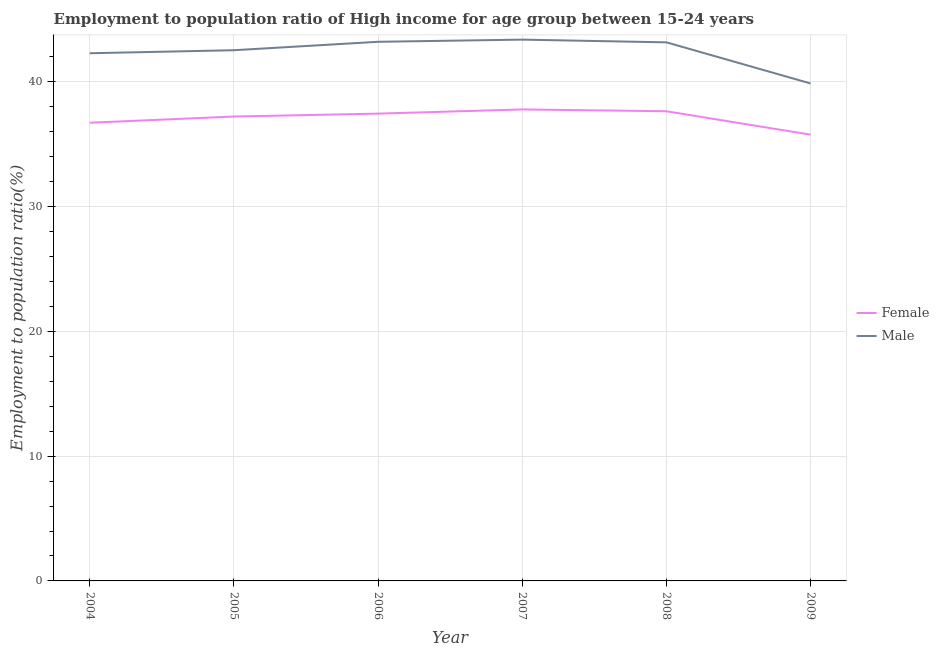How many different coloured lines are there?
Provide a succinct answer. 2. Does the line corresponding to employment to population ratio(female) intersect with the line corresponding to employment to population ratio(male)?
Give a very brief answer. No. Is the number of lines equal to the number of legend labels?
Offer a terse response. Yes. What is the employment to population ratio(male) in 2006?
Give a very brief answer. 43.22. Across all years, what is the maximum employment to population ratio(male)?
Give a very brief answer. 43.39. Across all years, what is the minimum employment to population ratio(female)?
Your answer should be very brief. 35.77. In which year was the employment to population ratio(female) maximum?
Offer a terse response. 2007. What is the total employment to population ratio(female) in the graph?
Offer a very short reply. 222.62. What is the difference between the employment to population ratio(male) in 2005 and that in 2006?
Keep it short and to the point. -0.68. What is the difference between the employment to population ratio(female) in 2004 and the employment to population ratio(male) in 2006?
Make the answer very short. -6.49. What is the average employment to population ratio(female) per year?
Keep it short and to the point. 37.1. In the year 2009, what is the difference between the employment to population ratio(male) and employment to population ratio(female)?
Give a very brief answer. 4.1. In how many years, is the employment to population ratio(female) greater than 14 %?
Offer a very short reply. 6. What is the ratio of the employment to population ratio(male) in 2005 to that in 2008?
Make the answer very short. 0.99. Is the difference between the employment to population ratio(female) in 2007 and 2009 greater than the difference between the employment to population ratio(male) in 2007 and 2009?
Your answer should be very brief. No. What is the difference between the highest and the second highest employment to population ratio(male)?
Offer a very short reply. 0.17. What is the difference between the highest and the lowest employment to population ratio(male)?
Provide a short and direct response. 3.51. In how many years, is the employment to population ratio(male) greater than the average employment to population ratio(male) taken over all years?
Offer a terse response. 4. Is the sum of the employment to population ratio(female) in 2006 and 2009 greater than the maximum employment to population ratio(male) across all years?
Provide a short and direct response. Yes. Does the employment to population ratio(male) monotonically increase over the years?
Keep it short and to the point. No. How many lines are there?
Make the answer very short. 2. What is the difference between two consecutive major ticks on the Y-axis?
Ensure brevity in your answer.  10. Does the graph contain grids?
Give a very brief answer. Yes. Where does the legend appear in the graph?
Offer a very short reply. Center right. How many legend labels are there?
Provide a succinct answer. 2. What is the title of the graph?
Provide a short and direct response. Employment to population ratio of High income for age group between 15-24 years. Does "Infant" appear as one of the legend labels in the graph?
Give a very brief answer. No. What is the label or title of the X-axis?
Keep it short and to the point. Year. What is the Employment to population ratio(%) in Female in 2004?
Provide a short and direct response. 36.73. What is the Employment to population ratio(%) of Male in 2004?
Offer a terse response. 42.3. What is the Employment to population ratio(%) in Female in 2005?
Offer a very short reply. 37.23. What is the Employment to population ratio(%) in Male in 2005?
Offer a very short reply. 42.54. What is the Employment to population ratio(%) in Female in 2006?
Ensure brevity in your answer.  37.46. What is the Employment to population ratio(%) of Male in 2006?
Give a very brief answer. 43.22. What is the Employment to population ratio(%) in Female in 2007?
Your answer should be very brief. 37.79. What is the Employment to population ratio(%) of Male in 2007?
Provide a succinct answer. 43.39. What is the Employment to population ratio(%) in Female in 2008?
Give a very brief answer. 37.65. What is the Employment to population ratio(%) in Male in 2008?
Offer a very short reply. 43.17. What is the Employment to population ratio(%) of Female in 2009?
Provide a succinct answer. 35.77. What is the Employment to population ratio(%) of Male in 2009?
Make the answer very short. 39.88. Across all years, what is the maximum Employment to population ratio(%) in Female?
Make the answer very short. 37.79. Across all years, what is the maximum Employment to population ratio(%) in Male?
Make the answer very short. 43.39. Across all years, what is the minimum Employment to population ratio(%) in Female?
Your response must be concise. 35.77. Across all years, what is the minimum Employment to population ratio(%) of Male?
Provide a succinct answer. 39.88. What is the total Employment to population ratio(%) in Female in the graph?
Provide a short and direct response. 222.62. What is the total Employment to population ratio(%) of Male in the graph?
Give a very brief answer. 254.49. What is the difference between the Employment to population ratio(%) of Female in 2004 and that in 2005?
Keep it short and to the point. -0.5. What is the difference between the Employment to population ratio(%) of Male in 2004 and that in 2005?
Offer a very short reply. -0.24. What is the difference between the Employment to population ratio(%) of Female in 2004 and that in 2006?
Make the answer very short. -0.73. What is the difference between the Employment to population ratio(%) of Male in 2004 and that in 2006?
Keep it short and to the point. -0.92. What is the difference between the Employment to population ratio(%) in Female in 2004 and that in 2007?
Your response must be concise. -1.07. What is the difference between the Employment to population ratio(%) in Male in 2004 and that in 2007?
Offer a very short reply. -1.09. What is the difference between the Employment to population ratio(%) of Female in 2004 and that in 2008?
Offer a terse response. -0.92. What is the difference between the Employment to population ratio(%) of Male in 2004 and that in 2008?
Offer a very short reply. -0.87. What is the difference between the Employment to population ratio(%) in Female in 2004 and that in 2009?
Offer a very short reply. 0.96. What is the difference between the Employment to population ratio(%) in Male in 2004 and that in 2009?
Ensure brevity in your answer.  2.42. What is the difference between the Employment to population ratio(%) of Female in 2005 and that in 2006?
Your response must be concise. -0.23. What is the difference between the Employment to population ratio(%) of Male in 2005 and that in 2006?
Keep it short and to the point. -0.68. What is the difference between the Employment to population ratio(%) in Female in 2005 and that in 2007?
Your answer should be very brief. -0.57. What is the difference between the Employment to population ratio(%) of Male in 2005 and that in 2007?
Provide a succinct answer. -0.85. What is the difference between the Employment to population ratio(%) in Female in 2005 and that in 2008?
Your answer should be very brief. -0.42. What is the difference between the Employment to population ratio(%) in Male in 2005 and that in 2008?
Give a very brief answer. -0.63. What is the difference between the Employment to population ratio(%) of Female in 2005 and that in 2009?
Make the answer very short. 1.45. What is the difference between the Employment to population ratio(%) of Male in 2005 and that in 2009?
Give a very brief answer. 2.66. What is the difference between the Employment to population ratio(%) of Female in 2006 and that in 2007?
Your response must be concise. -0.34. What is the difference between the Employment to population ratio(%) in Male in 2006 and that in 2007?
Provide a succinct answer. -0.17. What is the difference between the Employment to population ratio(%) in Female in 2006 and that in 2008?
Ensure brevity in your answer.  -0.19. What is the difference between the Employment to population ratio(%) in Male in 2006 and that in 2008?
Keep it short and to the point. 0.04. What is the difference between the Employment to population ratio(%) of Female in 2006 and that in 2009?
Provide a succinct answer. 1.69. What is the difference between the Employment to population ratio(%) in Male in 2006 and that in 2009?
Keep it short and to the point. 3.34. What is the difference between the Employment to population ratio(%) of Female in 2007 and that in 2008?
Provide a short and direct response. 0.15. What is the difference between the Employment to population ratio(%) of Male in 2007 and that in 2008?
Make the answer very short. 0.22. What is the difference between the Employment to population ratio(%) of Female in 2007 and that in 2009?
Your answer should be very brief. 2.02. What is the difference between the Employment to population ratio(%) in Male in 2007 and that in 2009?
Ensure brevity in your answer.  3.51. What is the difference between the Employment to population ratio(%) in Female in 2008 and that in 2009?
Your response must be concise. 1.88. What is the difference between the Employment to population ratio(%) of Male in 2008 and that in 2009?
Your answer should be very brief. 3.3. What is the difference between the Employment to population ratio(%) in Female in 2004 and the Employment to population ratio(%) in Male in 2005?
Make the answer very short. -5.81. What is the difference between the Employment to population ratio(%) in Female in 2004 and the Employment to population ratio(%) in Male in 2006?
Your response must be concise. -6.49. What is the difference between the Employment to population ratio(%) of Female in 2004 and the Employment to population ratio(%) of Male in 2007?
Your answer should be compact. -6.66. What is the difference between the Employment to population ratio(%) of Female in 2004 and the Employment to population ratio(%) of Male in 2008?
Your response must be concise. -6.44. What is the difference between the Employment to population ratio(%) of Female in 2004 and the Employment to population ratio(%) of Male in 2009?
Give a very brief answer. -3.15. What is the difference between the Employment to population ratio(%) of Female in 2005 and the Employment to population ratio(%) of Male in 2006?
Make the answer very short. -5.99. What is the difference between the Employment to population ratio(%) of Female in 2005 and the Employment to population ratio(%) of Male in 2007?
Provide a short and direct response. -6.16. What is the difference between the Employment to population ratio(%) in Female in 2005 and the Employment to population ratio(%) in Male in 2008?
Your answer should be compact. -5.95. What is the difference between the Employment to population ratio(%) of Female in 2005 and the Employment to population ratio(%) of Male in 2009?
Provide a short and direct response. -2.65. What is the difference between the Employment to population ratio(%) of Female in 2006 and the Employment to population ratio(%) of Male in 2007?
Keep it short and to the point. -5.93. What is the difference between the Employment to population ratio(%) of Female in 2006 and the Employment to population ratio(%) of Male in 2008?
Make the answer very short. -5.71. What is the difference between the Employment to population ratio(%) of Female in 2006 and the Employment to population ratio(%) of Male in 2009?
Ensure brevity in your answer.  -2.42. What is the difference between the Employment to population ratio(%) in Female in 2007 and the Employment to population ratio(%) in Male in 2008?
Ensure brevity in your answer.  -5.38. What is the difference between the Employment to population ratio(%) of Female in 2007 and the Employment to population ratio(%) of Male in 2009?
Your response must be concise. -2.08. What is the difference between the Employment to population ratio(%) of Female in 2008 and the Employment to population ratio(%) of Male in 2009?
Your answer should be very brief. -2.23. What is the average Employment to population ratio(%) in Female per year?
Keep it short and to the point. 37.1. What is the average Employment to population ratio(%) in Male per year?
Your response must be concise. 42.42. In the year 2004, what is the difference between the Employment to population ratio(%) of Female and Employment to population ratio(%) of Male?
Make the answer very short. -5.57. In the year 2005, what is the difference between the Employment to population ratio(%) in Female and Employment to population ratio(%) in Male?
Provide a short and direct response. -5.32. In the year 2006, what is the difference between the Employment to population ratio(%) of Female and Employment to population ratio(%) of Male?
Offer a terse response. -5.76. In the year 2007, what is the difference between the Employment to population ratio(%) in Female and Employment to population ratio(%) in Male?
Offer a very short reply. -5.6. In the year 2008, what is the difference between the Employment to population ratio(%) of Female and Employment to population ratio(%) of Male?
Provide a succinct answer. -5.52. In the year 2009, what is the difference between the Employment to population ratio(%) in Female and Employment to population ratio(%) in Male?
Your answer should be very brief. -4.1. What is the ratio of the Employment to population ratio(%) of Female in 2004 to that in 2005?
Offer a very short reply. 0.99. What is the ratio of the Employment to population ratio(%) of Female in 2004 to that in 2006?
Your answer should be compact. 0.98. What is the ratio of the Employment to population ratio(%) in Male in 2004 to that in 2006?
Keep it short and to the point. 0.98. What is the ratio of the Employment to population ratio(%) of Female in 2004 to that in 2007?
Your response must be concise. 0.97. What is the ratio of the Employment to population ratio(%) in Male in 2004 to that in 2007?
Provide a short and direct response. 0.97. What is the ratio of the Employment to population ratio(%) in Female in 2004 to that in 2008?
Keep it short and to the point. 0.98. What is the ratio of the Employment to population ratio(%) in Male in 2004 to that in 2008?
Ensure brevity in your answer.  0.98. What is the ratio of the Employment to population ratio(%) in Female in 2004 to that in 2009?
Ensure brevity in your answer.  1.03. What is the ratio of the Employment to population ratio(%) in Male in 2004 to that in 2009?
Offer a terse response. 1.06. What is the ratio of the Employment to population ratio(%) in Male in 2005 to that in 2006?
Offer a very short reply. 0.98. What is the ratio of the Employment to population ratio(%) in Female in 2005 to that in 2007?
Keep it short and to the point. 0.98. What is the ratio of the Employment to population ratio(%) in Male in 2005 to that in 2007?
Keep it short and to the point. 0.98. What is the ratio of the Employment to population ratio(%) in Male in 2005 to that in 2008?
Give a very brief answer. 0.99. What is the ratio of the Employment to population ratio(%) of Female in 2005 to that in 2009?
Provide a short and direct response. 1.04. What is the ratio of the Employment to population ratio(%) in Male in 2005 to that in 2009?
Offer a terse response. 1.07. What is the ratio of the Employment to population ratio(%) of Male in 2006 to that in 2007?
Ensure brevity in your answer.  1. What is the ratio of the Employment to population ratio(%) in Male in 2006 to that in 2008?
Offer a very short reply. 1. What is the ratio of the Employment to population ratio(%) of Female in 2006 to that in 2009?
Keep it short and to the point. 1.05. What is the ratio of the Employment to population ratio(%) in Male in 2006 to that in 2009?
Your answer should be very brief. 1.08. What is the ratio of the Employment to population ratio(%) of Female in 2007 to that in 2008?
Give a very brief answer. 1. What is the ratio of the Employment to population ratio(%) of Female in 2007 to that in 2009?
Your response must be concise. 1.06. What is the ratio of the Employment to population ratio(%) in Male in 2007 to that in 2009?
Ensure brevity in your answer.  1.09. What is the ratio of the Employment to population ratio(%) of Female in 2008 to that in 2009?
Provide a short and direct response. 1.05. What is the ratio of the Employment to population ratio(%) of Male in 2008 to that in 2009?
Ensure brevity in your answer.  1.08. What is the difference between the highest and the second highest Employment to population ratio(%) of Female?
Your answer should be very brief. 0.15. What is the difference between the highest and the second highest Employment to population ratio(%) of Male?
Your answer should be very brief. 0.17. What is the difference between the highest and the lowest Employment to population ratio(%) of Female?
Offer a terse response. 2.02. What is the difference between the highest and the lowest Employment to population ratio(%) of Male?
Offer a terse response. 3.51. 